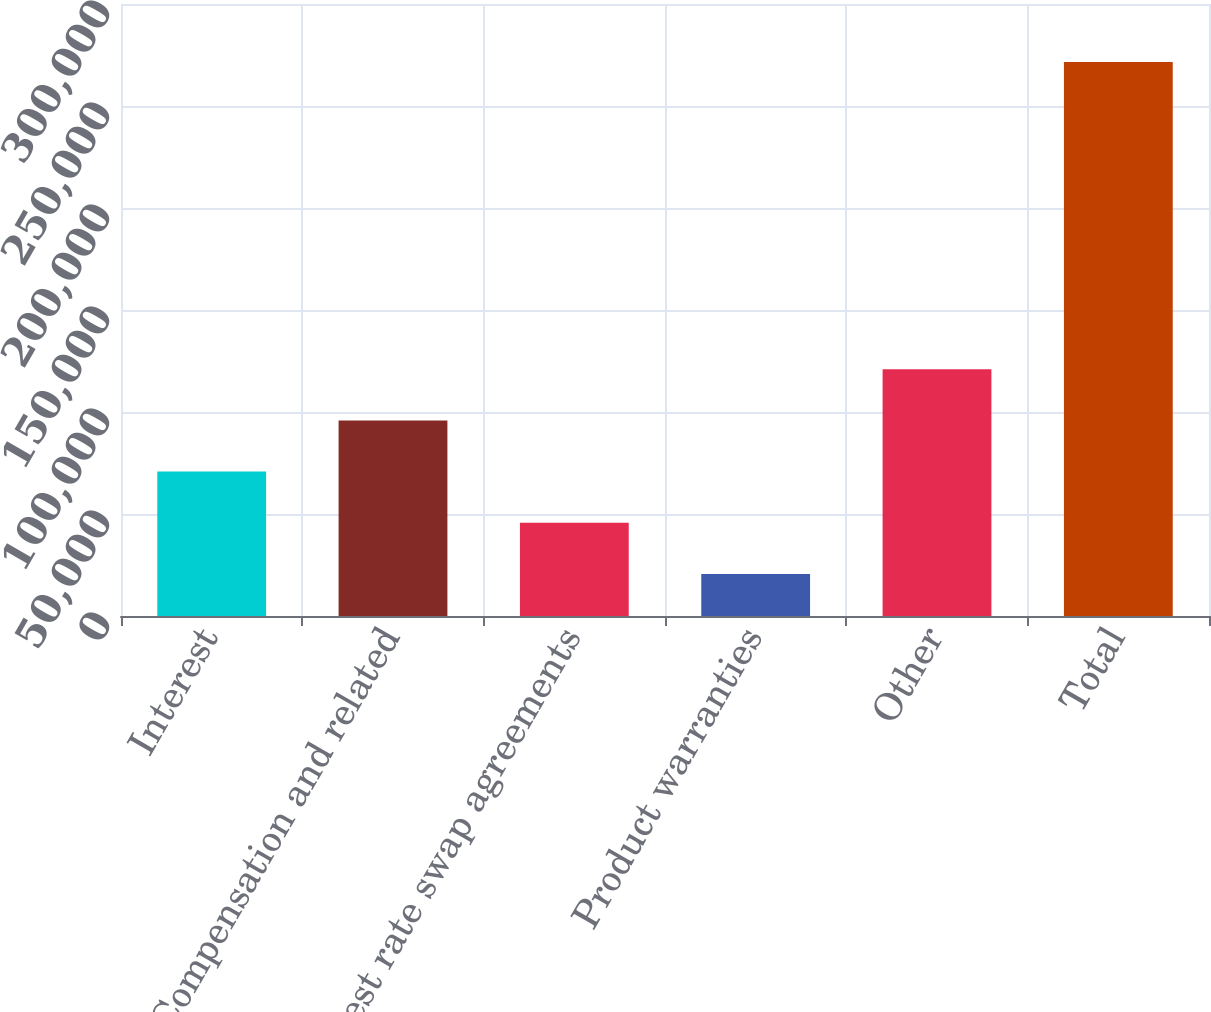Convert chart to OTSL. <chart><loc_0><loc_0><loc_500><loc_500><bar_chart><fcel>Interest<fcel>Compensation and related<fcel>Interest rate swap agreements<fcel>Product warranties<fcel>Other<fcel>Total<nl><fcel>70784.2<fcel>95880.3<fcel>45688.1<fcel>20592<fcel>120976<fcel>271553<nl></chart> 